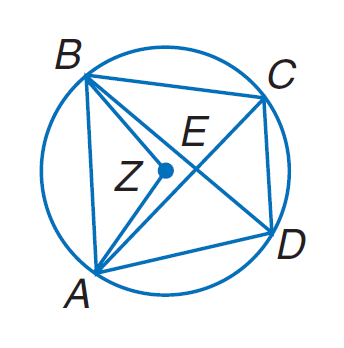Answer the mathemtical geometry problem and directly provide the correct option letter.
Question: Quadrilateral A B C D is inscribed in \odot Z such that m \angle B Z A = 104, m \widehat C B = 94, and A B \parallel D C. Find m \widehat A D C.
Choices: A: 36 B: 90 C: 120 D: 162 D 